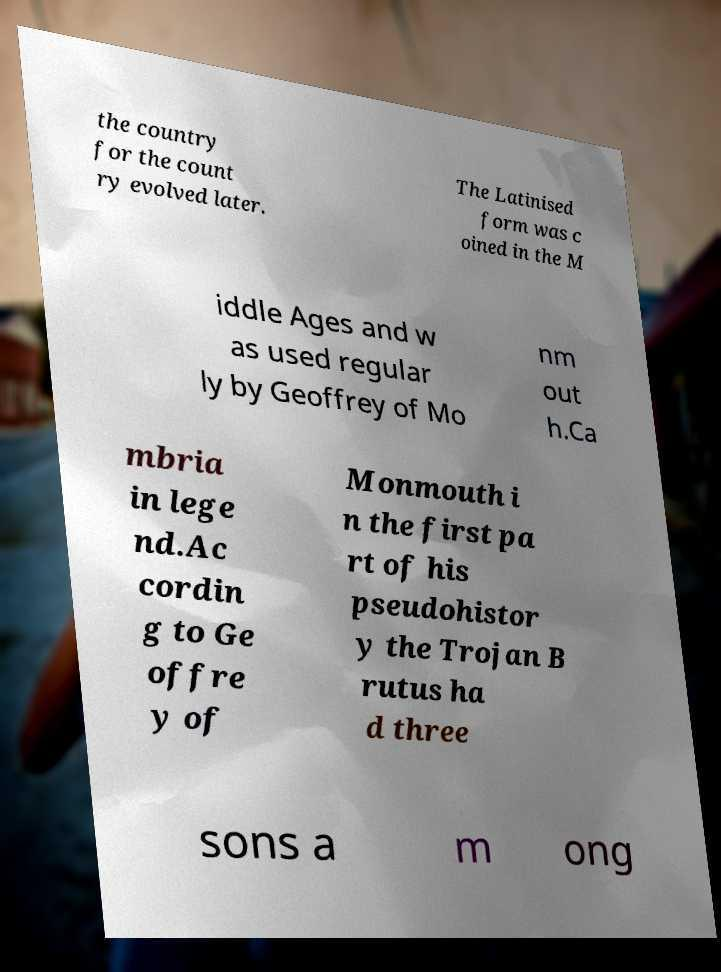Can you read and provide the text displayed in the image?This photo seems to have some interesting text. Can you extract and type it out for me? the country for the count ry evolved later. The Latinised form was c oined in the M iddle Ages and w as used regular ly by Geoffrey of Mo nm out h.Ca mbria in lege nd.Ac cordin g to Ge offre y of Monmouth i n the first pa rt of his pseudohistor y the Trojan B rutus ha d three sons a m ong 